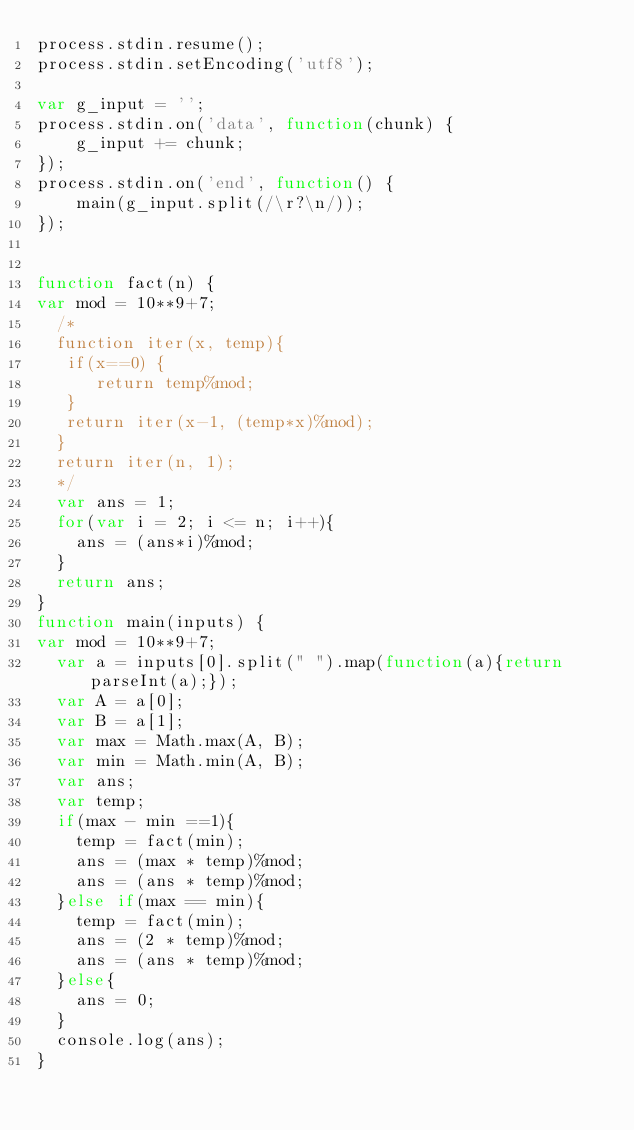<code> <loc_0><loc_0><loc_500><loc_500><_JavaScript_>process.stdin.resume();
process.stdin.setEncoding('utf8');

var g_input = '';
process.stdin.on('data', function(chunk) {
    g_input += chunk;
});
process.stdin.on('end', function() {
    main(g_input.split(/\r?\n/));
});


function fact(n) {
var mod = 10**9+7;
  /*
  function iter(x, temp){
   if(x==0) {
      return temp%mod;
   }
   return iter(x-1, (temp*x)%mod);
  }
  return iter(n, 1);
  */
  var ans = 1;
  for(var i = 2; i <= n; i++){
    ans = (ans*i)%mod;
  }
  return ans;
}
function main(inputs) {
var mod = 10**9+7;
  var a = inputs[0].split(" ").map(function(a){return parseInt(a);});
  var A = a[0];
  var B = a[1];
  var max = Math.max(A, B);
  var min = Math.min(A, B);
  var ans;
  var temp;
  if(max - min ==1){
    temp = fact(min);
    ans = (max * temp)%mod;
    ans = (ans * temp)%mod;
  }else if(max == min){
    temp = fact(min);
    ans = (2 * temp)%mod;
    ans = (ans * temp)%mod;
  }else{
    ans = 0;
  }
  console.log(ans);
}
</code> 